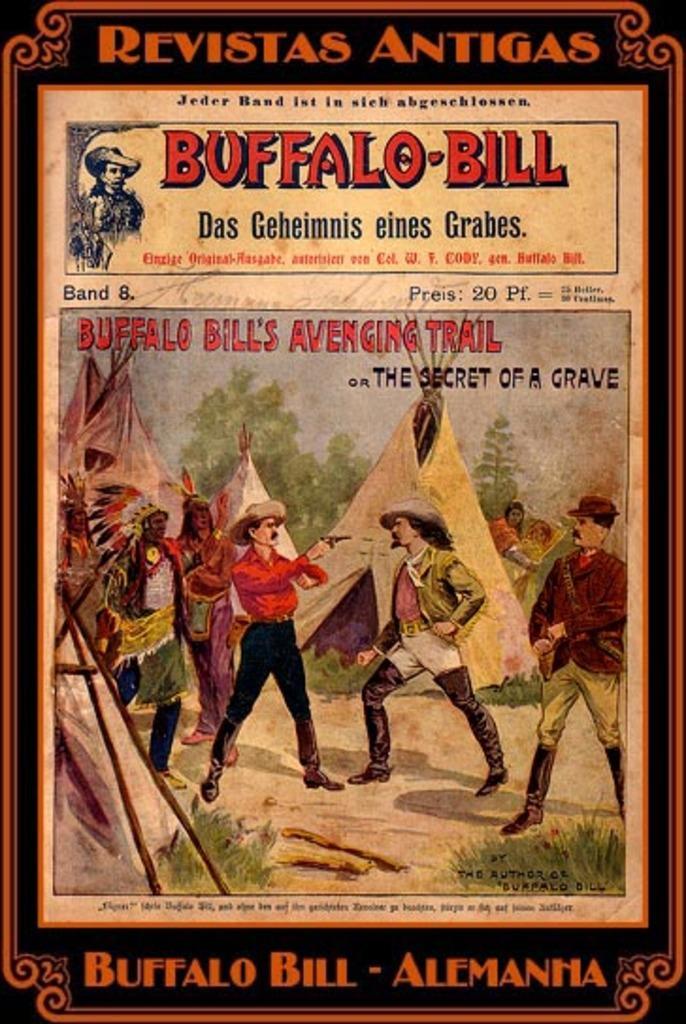Can you describe this image briefly? In this image we can see a poster in which we can see a group of people standing on the ground. One man is holding a gun in his hand. In the background, we can see some tents, grass and some trees. At the bottom of the image we can see some text. 